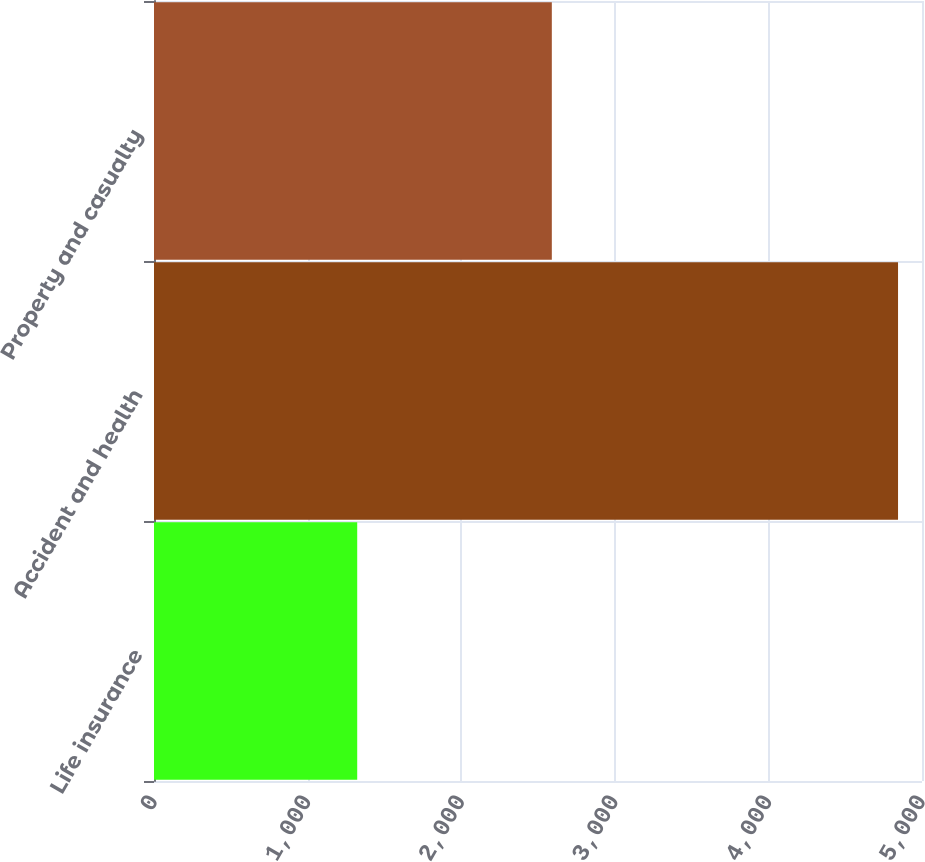<chart> <loc_0><loc_0><loc_500><loc_500><bar_chart><fcel>Life insurance<fcel>Accident and health<fcel>Property and casualty<nl><fcel>1323<fcel>4844<fcel>2590<nl></chart> 